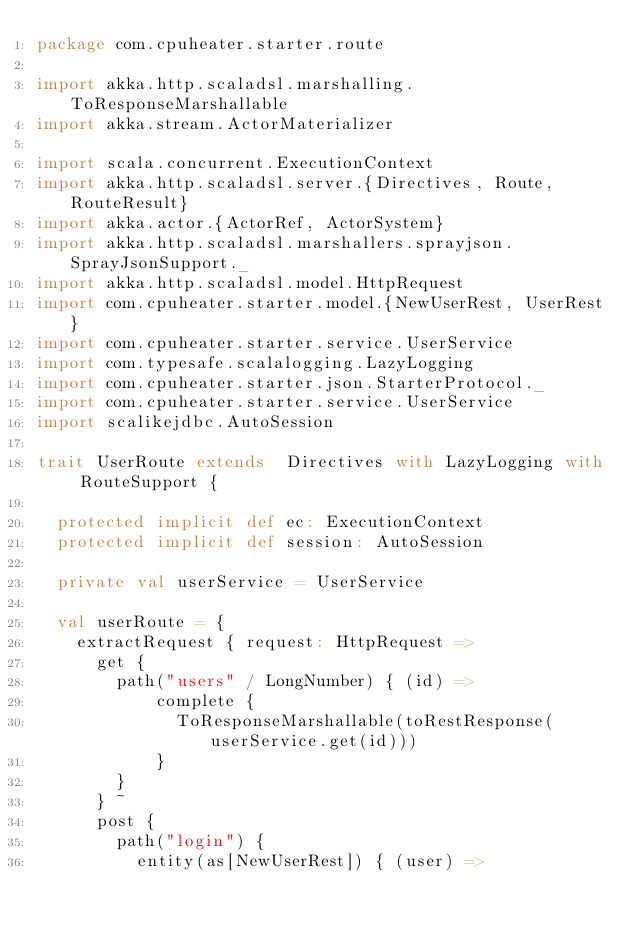Convert code to text. <code><loc_0><loc_0><loc_500><loc_500><_Scala_>package com.cpuheater.starter.route

import akka.http.scaladsl.marshalling.ToResponseMarshallable
import akka.stream.ActorMaterializer

import scala.concurrent.ExecutionContext
import akka.http.scaladsl.server.{Directives, Route, RouteResult}
import akka.actor.{ActorRef, ActorSystem}
import akka.http.scaladsl.marshallers.sprayjson.SprayJsonSupport._
import akka.http.scaladsl.model.HttpRequest
import com.cpuheater.starter.model.{NewUserRest, UserRest}
import com.cpuheater.starter.service.UserService
import com.typesafe.scalalogging.LazyLogging
import com.cpuheater.starter.json.StarterProtocol._
import com.cpuheater.starter.service.UserService
import scalikejdbc.AutoSession

trait UserRoute extends  Directives with LazyLogging with RouteSupport {

  protected implicit def ec: ExecutionContext
  protected implicit def session: AutoSession

  private val userService = UserService

  val userRoute = {
    extractRequest { request: HttpRequest =>
      get {
        path("users" / LongNumber) { (id) =>
            complete {
              ToResponseMarshallable(toRestResponse(userService.get(id)))
            }
        }
      } ~
      post {
        path("login") {
          entity(as[NewUserRest]) { (user) =></code> 